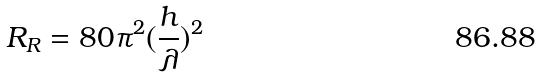<formula> <loc_0><loc_0><loc_500><loc_500>R _ { R } = 8 0 \pi ^ { 2 } ( \frac { h } { \lambda } ) ^ { 2 }</formula> 